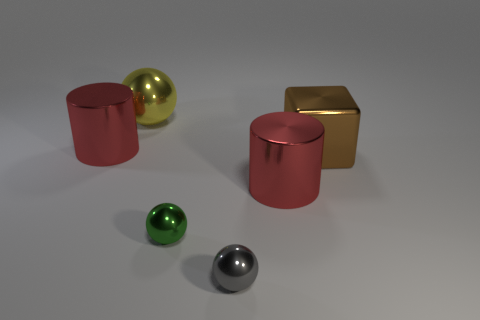Add 3 red shiny cylinders. How many objects exist? 9 Subtract all cubes. How many objects are left? 5 Add 4 brown things. How many brown things exist? 5 Subtract 0 blue cylinders. How many objects are left? 6 Subtract all big metal spheres. Subtract all gray things. How many objects are left? 4 Add 5 red shiny objects. How many red shiny objects are left? 7 